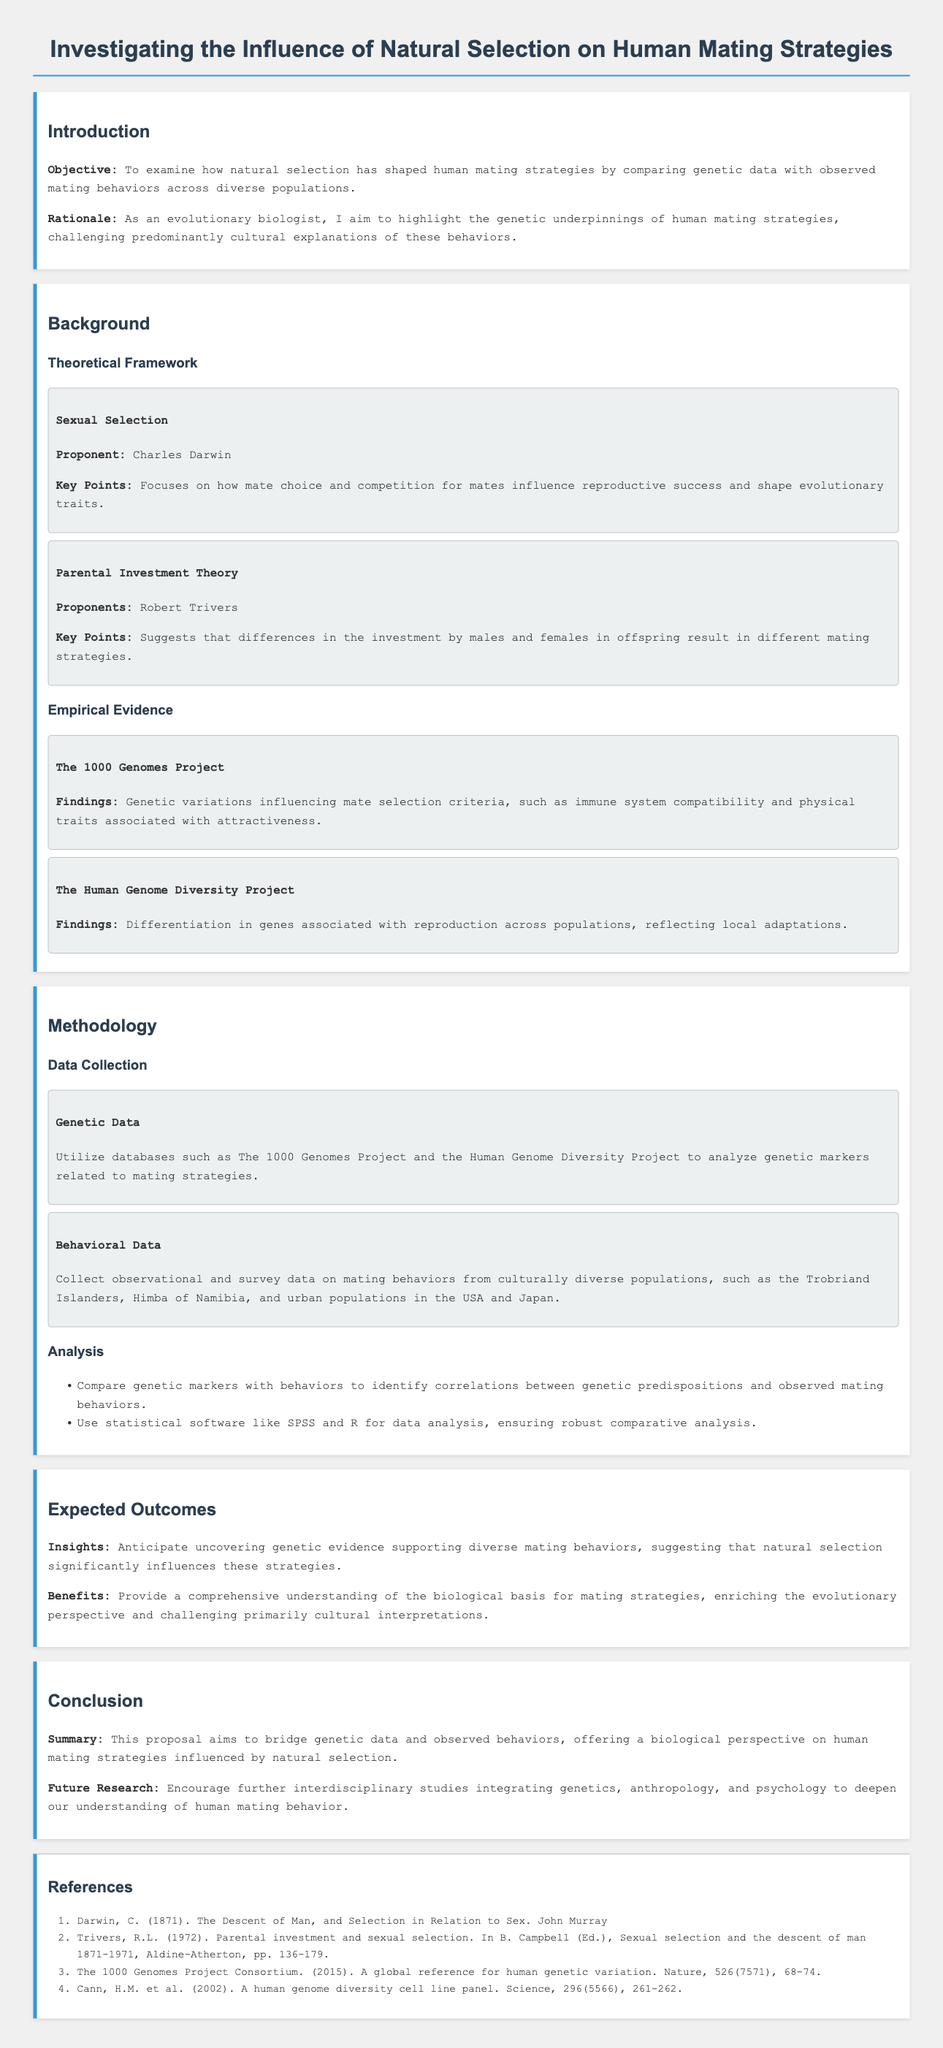What is the main objective of the proposal? The main objective is to examine how natural selection has shaped human mating strategies by comparing genetic data with observed mating behaviors across diverse populations.
Answer: To examine how natural selection has shaped human mating strategies Who proposed the Sexual Selection theory? The document states that Charles Darwin is the proponent of the Sexual Selection theory.
Answer: Charles Darwin What project provides genetic variations influencing mate selection criteria? The document mentions the 1000 Genomes Project as providing genetic variations influencing mate selection criteria.
Answer: The 1000 Genomes Project Which two populations are mentioned for collecting behavioral data? The document specifically mentions the Trobriand Islanders and urban populations in the USA and Japan for collecting behavioral data.
Answer: Trobriand Islanders, urban populations in the USA and Japan What statistical software will be used for data analysis? The document indicates that SPSS and R will be used for data analysis.
Answer: SPSS and R What does the proposal aim to challenge? The proposal aims to challenge predominantly cultural explanations of mating behaviors.
Answer: Predominantly cultural explanations What are the expected benefits of this research? The expected benefits include providing a comprehensive understanding of the biological basis for mating strategies.
Answer: A comprehensive understanding of the biological basis for mating strategies What interdisciplinary studies does the proposal encourage? The proposal encourages further interdisciplinary studies integrating genetics, anthropology, and psychology.
Answer: Genetics, anthropology, and psychology 